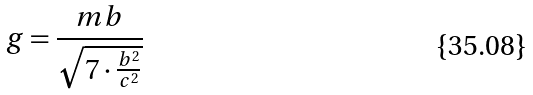<formula> <loc_0><loc_0><loc_500><loc_500>g = \frac { m b } { \sqrt { 7 \cdot \frac { b ^ { 2 } } { c ^ { 2 } } } }</formula> 